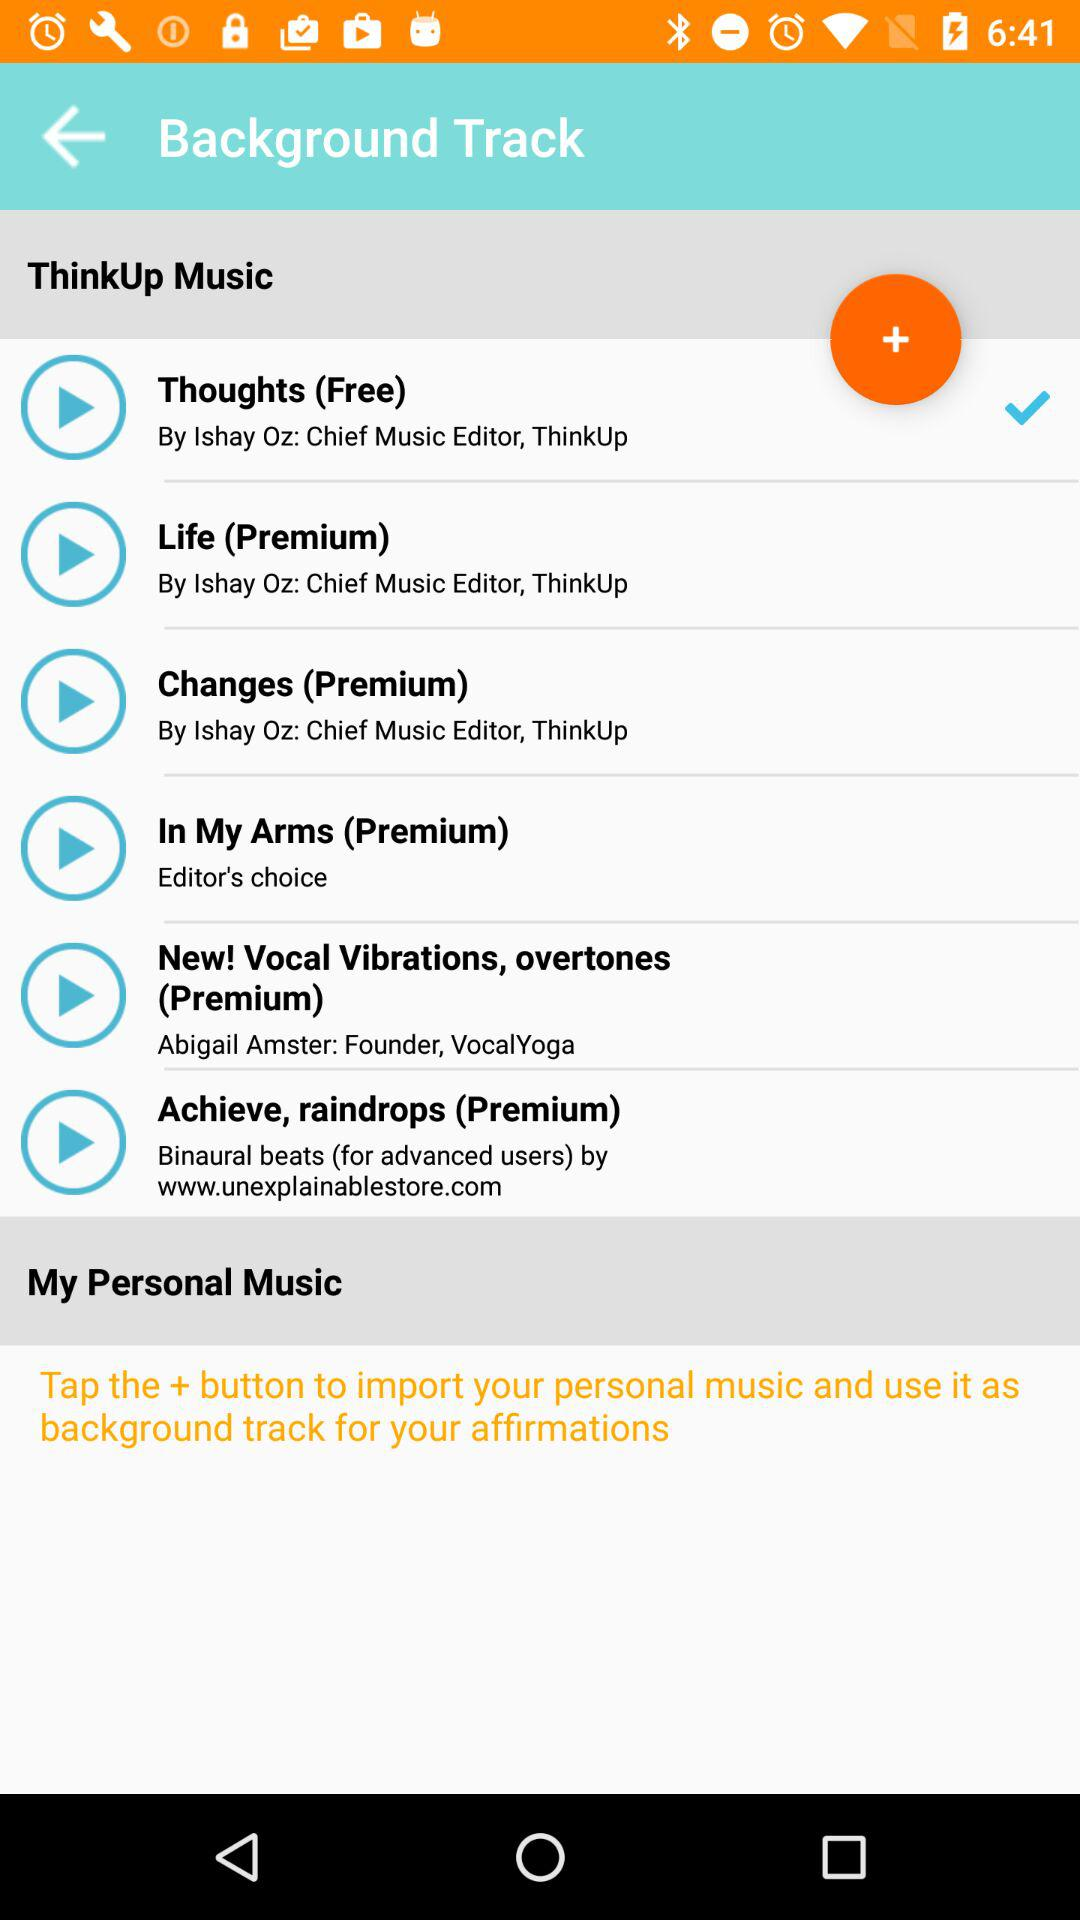Name the singer of song In my arms?
When the provided information is insufficient, respond with <no answer>. <no answer> 